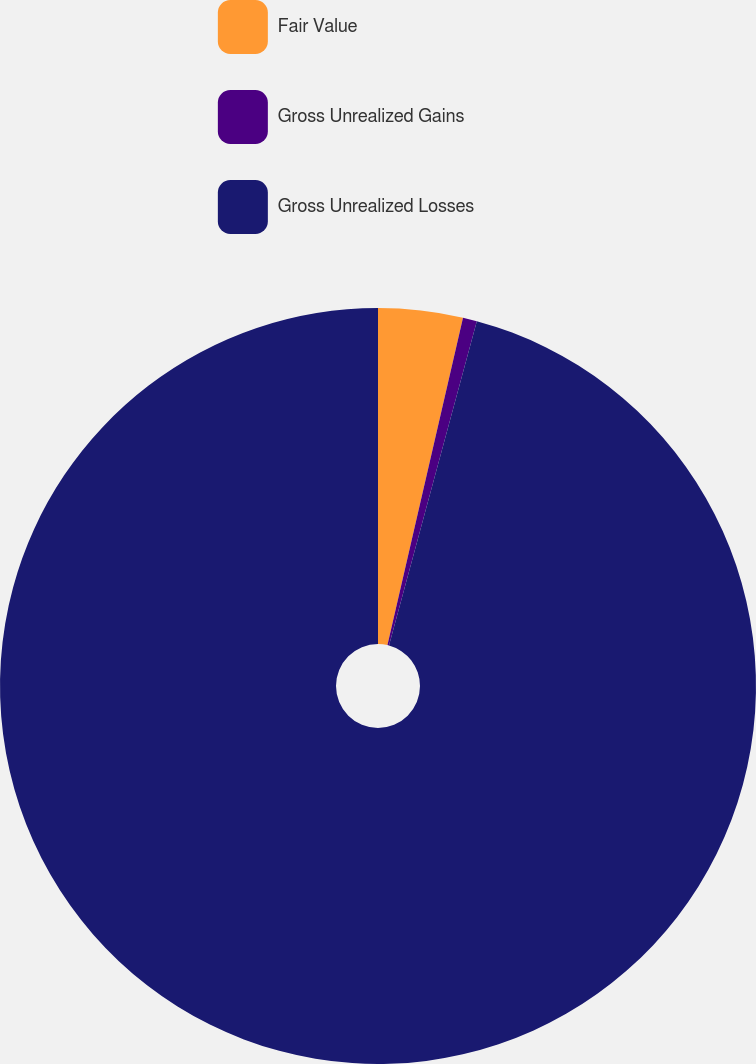Convert chart to OTSL. <chart><loc_0><loc_0><loc_500><loc_500><pie_chart><fcel>Fair Value<fcel>Gross Unrealized Gains<fcel>Gross Unrealized Losses<nl><fcel>3.61%<fcel>0.6%<fcel>95.79%<nl></chart> 